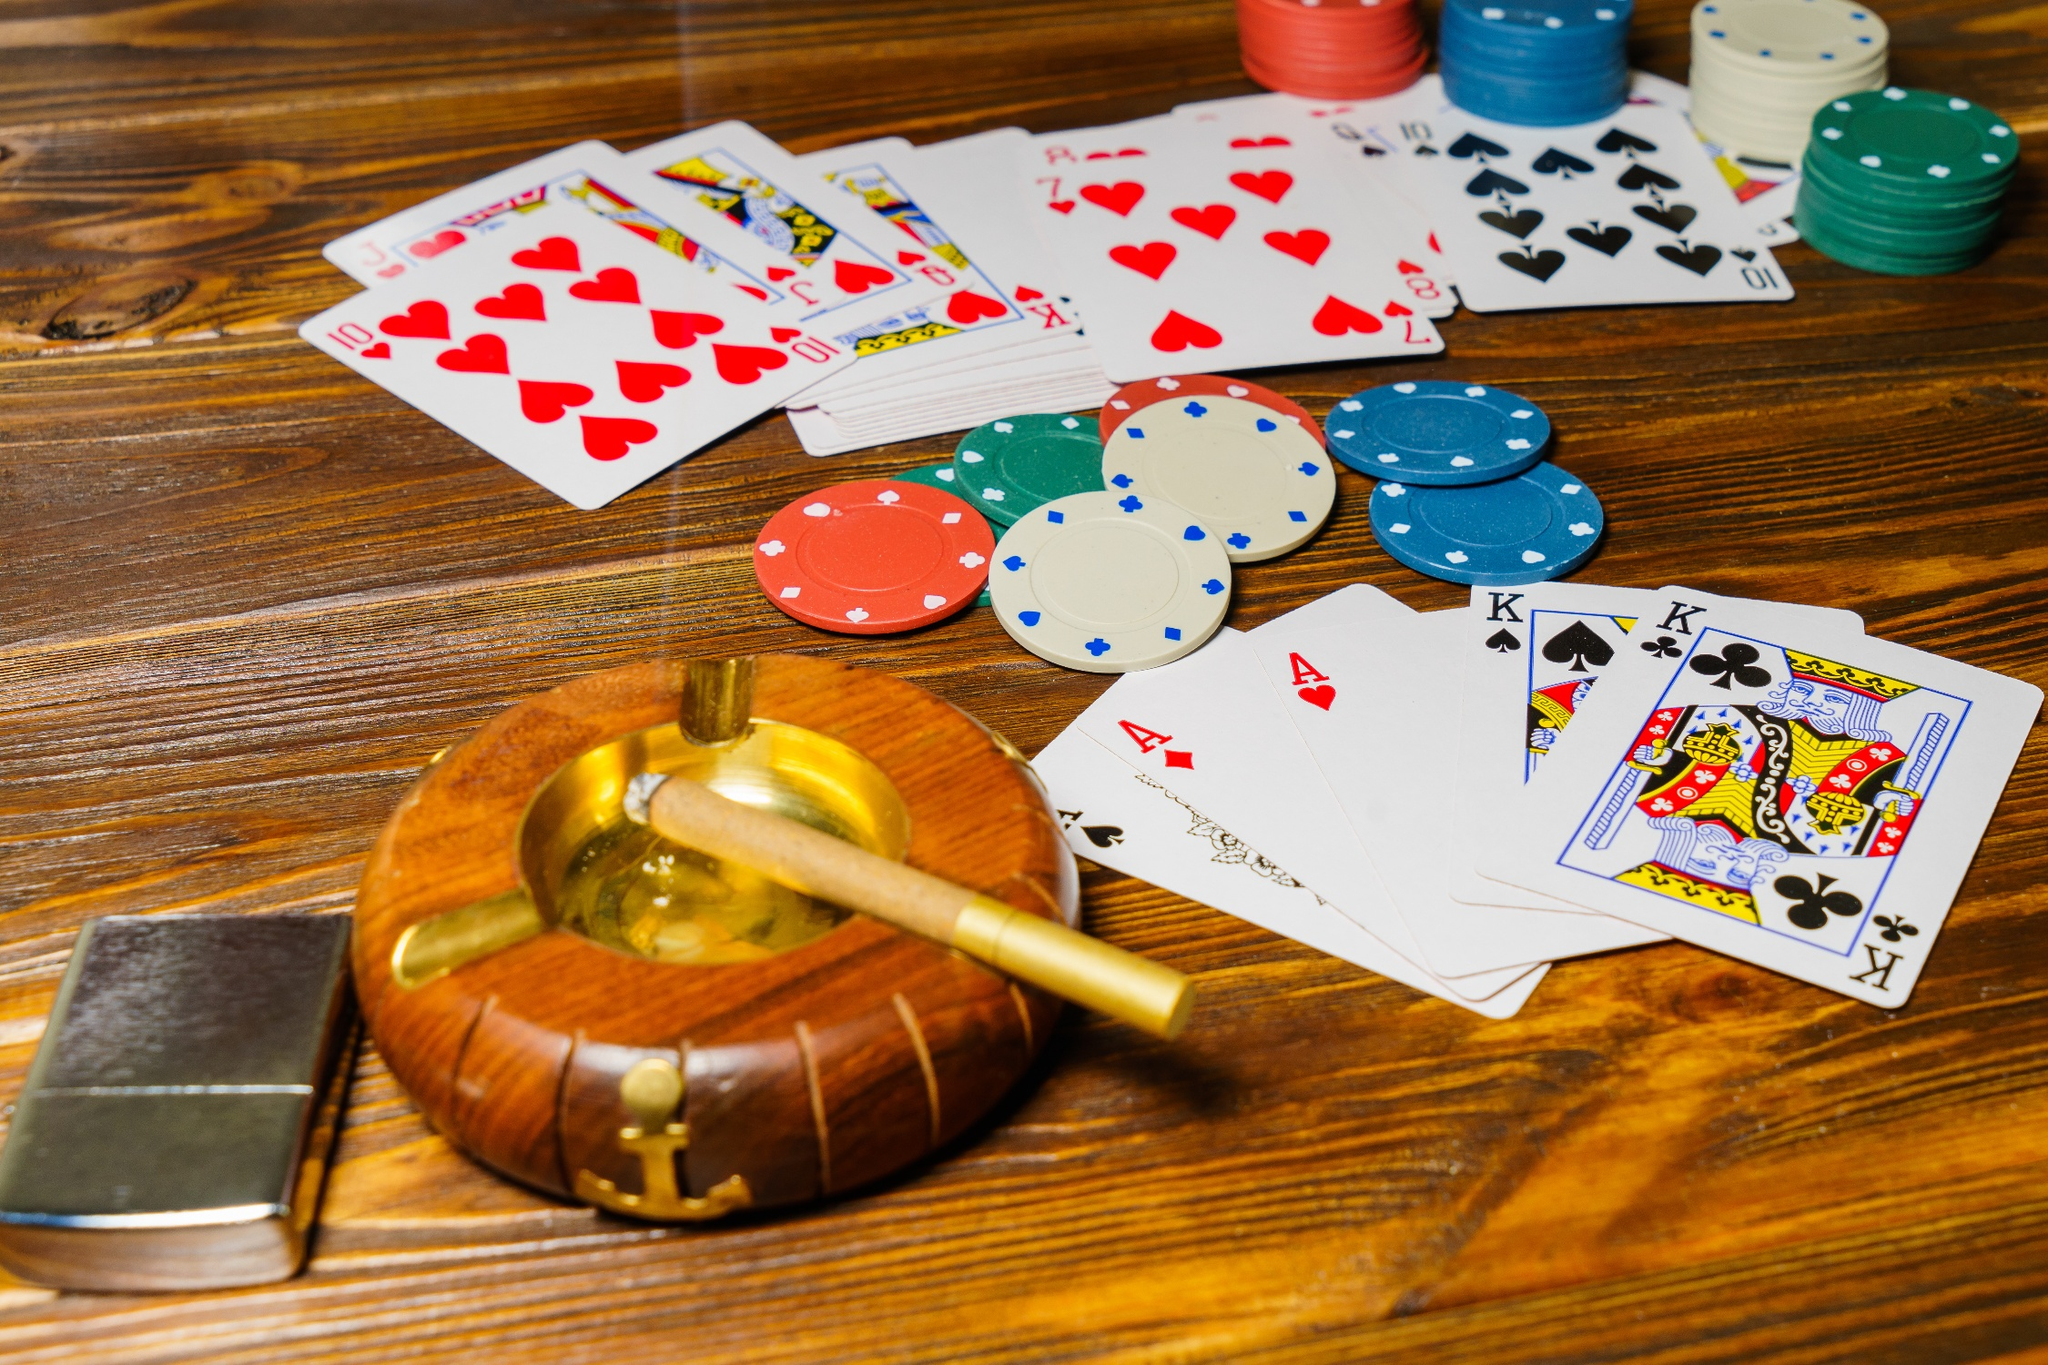If this image was a scene from a movie, what would the storyline be? In a thrilling heist movie, this poker game is the climactic scene where our protagonist, a genius card shark, is attempting to win crucial funds needed to pay off a dangerous debt. The game is tense, with each player's moves meticulously calculated. As the protagonist strategically places his bets, the camera zooms in on the cards and poker chips, cutting away to his nervously waiting associates. In a final, daring move, he wins the game with a Royal Flush, narrowly escaping capture by the mob. The scene captures the high-stakes gamble, the tension of the unknown, and the relief of a narrowly secured victory. What would be the wildcard twist in the storyline involving this poker game? In a wildcard twist, just as the protagonist begins to rake in his winnings, a hidden camera behind a painting reveals that the game was rigged. One of the players is actually an undercover FBI agent, who has been tracking the mob boss funding the poker night. With sudden urgency, the room is swarmed by federal agents, leading to a chaotic shootout. The protagonist, realizing the setup, skillfully manages to slip out unnoticed, only to find himself entangled in yet another web of crime and deception as he races to clear his name. 